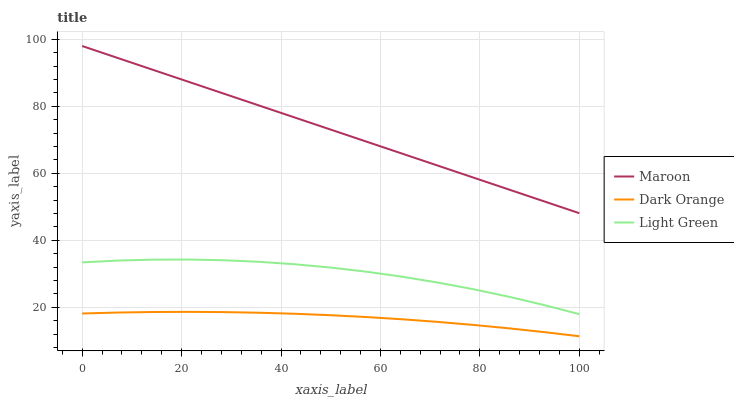Does Light Green have the minimum area under the curve?
Answer yes or no. No. Does Light Green have the maximum area under the curve?
Answer yes or no. No. Is Light Green the smoothest?
Answer yes or no. No. Is Maroon the roughest?
Answer yes or no. No. Does Light Green have the lowest value?
Answer yes or no. No. Does Light Green have the highest value?
Answer yes or no. No. Is Light Green less than Maroon?
Answer yes or no. Yes. Is Light Green greater than Dark Orange?
Answer yes or no. Yes. Does Light Green intersect Maroon?
Answer yes or no. No. 